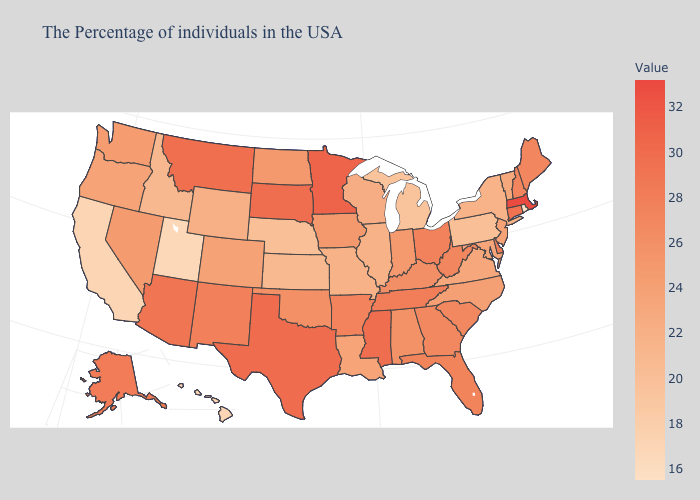Among the states that border Indiana , which have the lowest value?
Be succinct. Michigan. Which states hav the highest value in the South?
Answer briefly. Texas. Is the legend a continuous bar?
Write a very short answer. Yes. Does Nebraska have a lower value than Connecticut?
Write a very short answer. Yes. Does Rhode Island have the lowest value in the USA?
Concise answer only. Yes. 